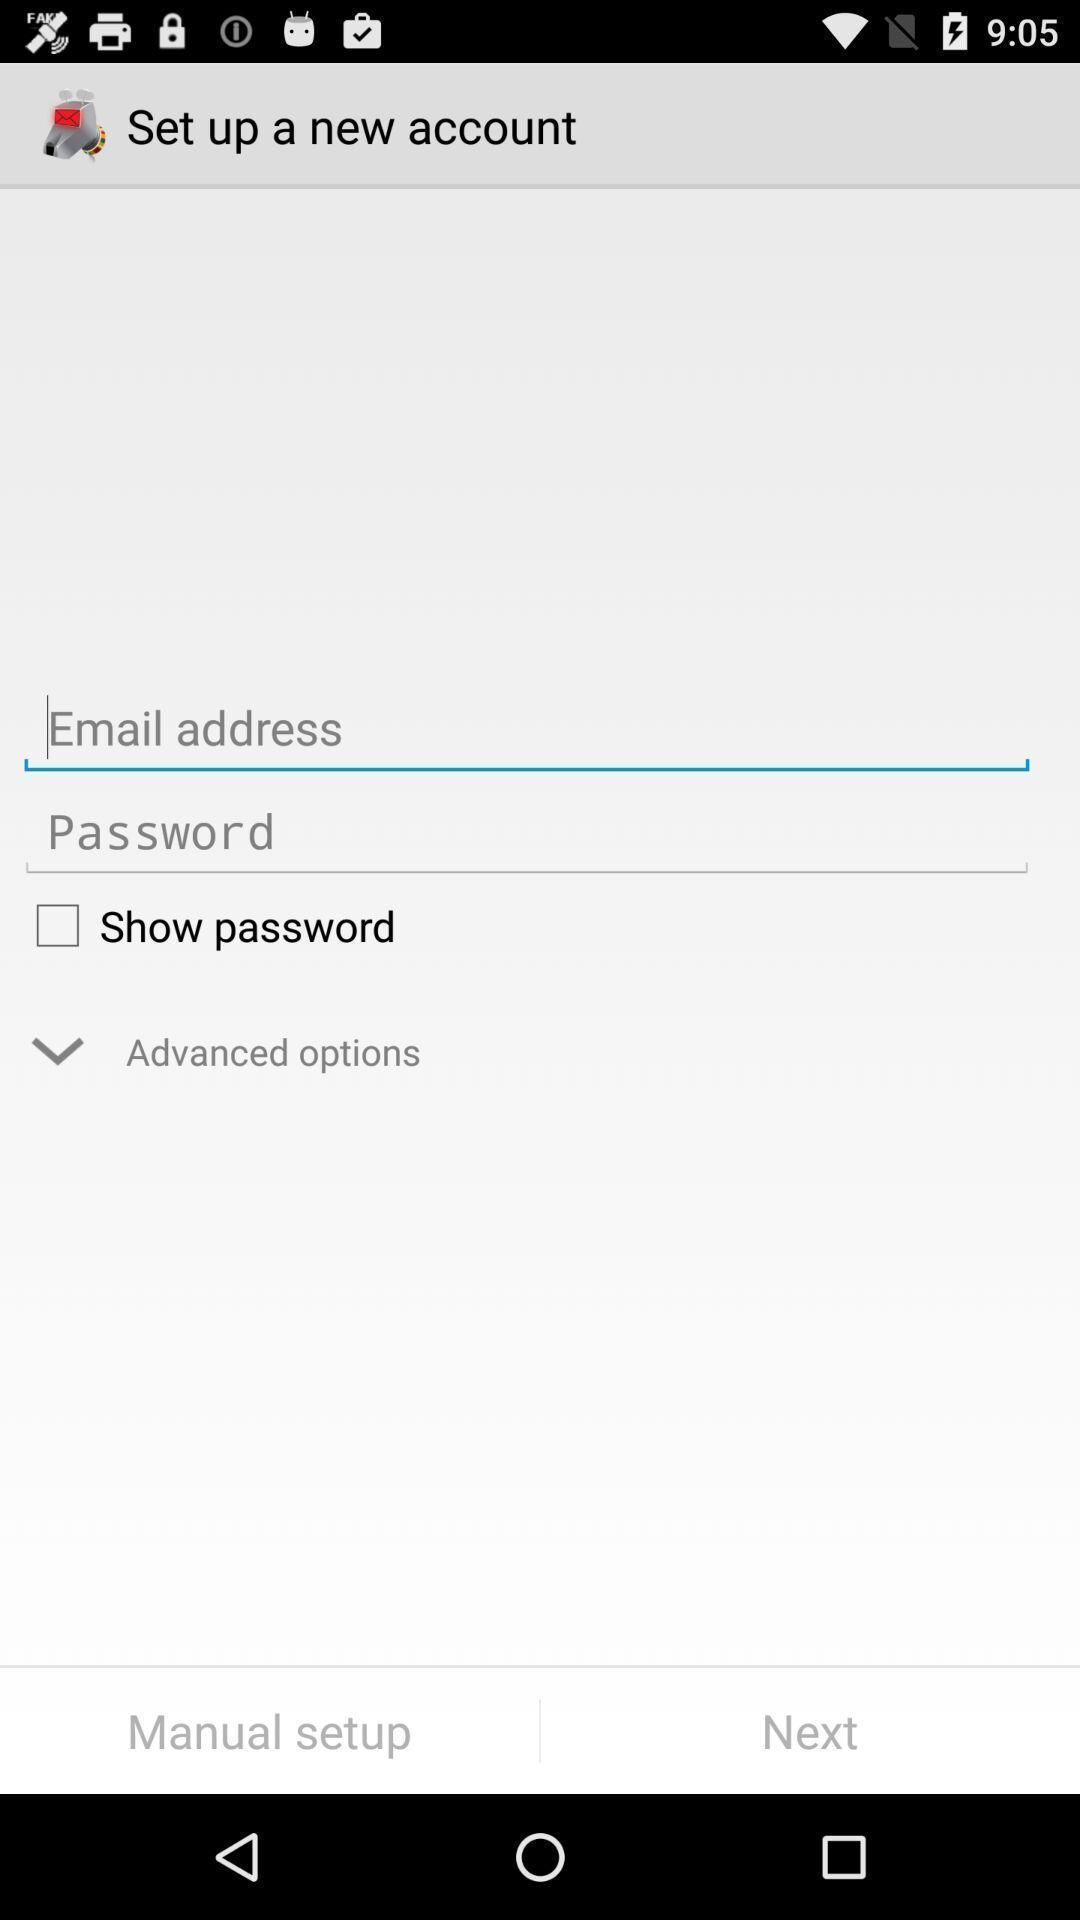Describe the content in this image. Page displaying to enter the details. 